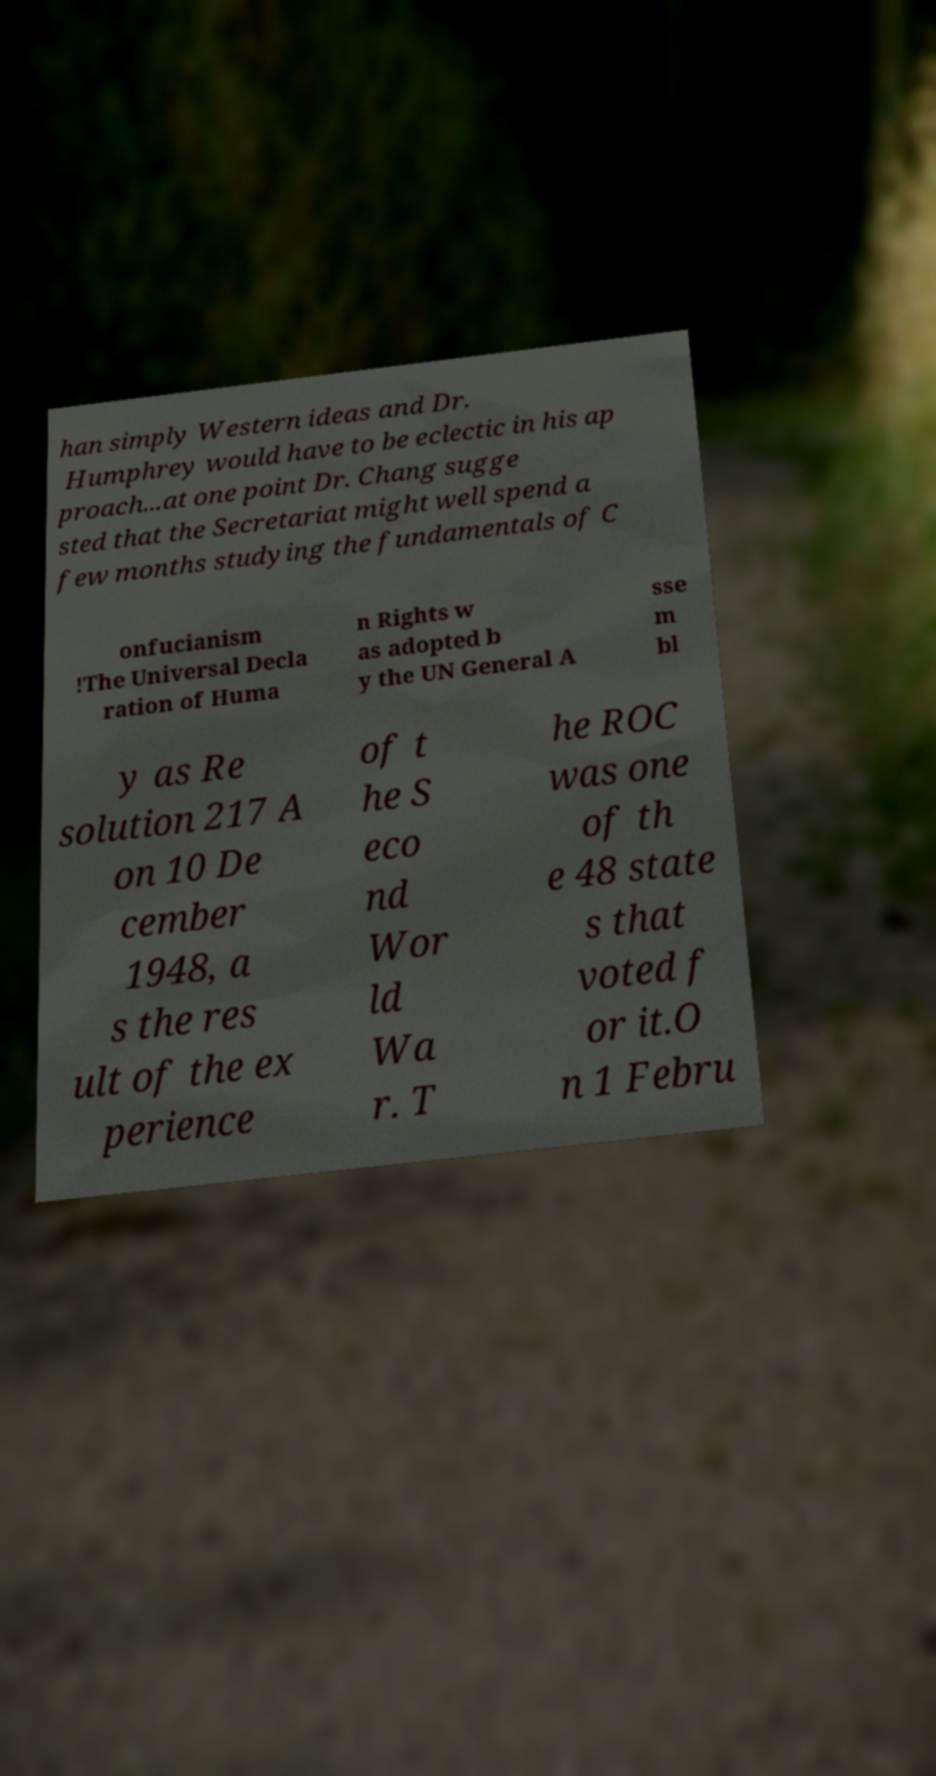For documentation purposes, I need the text within this image transcribed. Could you provide that? han simply Western ideas and Dr. Humphrey would have to be eclectic in his ap proach...at one point Dr. Chang sugge sted that the Secretariat might well spend a few months studying the fundamentals of C onfucianism !The Universal Decla ration of Huma n Rights w as adopted b y the UN General A sse m bl y as Re solution 217 A on 10 De cember 1948, a s the res ult of the ex perience of t he S eco nd Wor ld Wa r. T he ROC was one of th e 48 state s that voted f or it.O n 1 Febru 